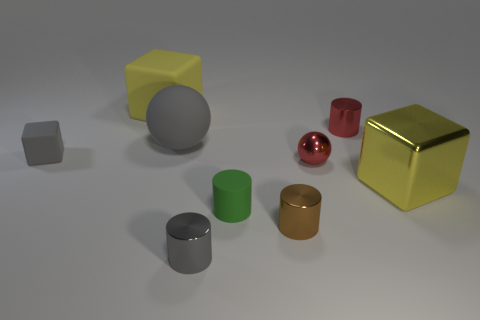The big matte cube has what color?
Offer a terse response. Yellow. Does the rubber sphere have the same color as the big rubber cube?
Provide a short and direct response. No. Does the ball on the right side of the tiny gray cylinder have the same material as the tiny cylinder that is to the right of the small red sphere?
Give a very brief answer. Yes. What is the material of the red thing that is the same shape as the brown metal thing?
Keep it short and to the point. Metal. Is the material of the gray cube the same as the brown object?
Provide a succinct answer. No. There is a block right of the tiny object to the right of the red sphere; what color is it?
Make the answer very short. Yellow. There is a red cylinder that is made of the same material as the tiny sphere; what size is it?
Your response must be concise. Small. What number of brown objects have the same shape as the tiny green object?
Offer a very short reply. 1. How many things are tiny things in front of the red shiny sphere or brown metal cylinders right of the tiny gray metal cylinder?
Your response must be concise. 3. How many tiny gray things are to the right of the yellow object in front of the rubber sphere?
Your answer should be very brief. 0. 